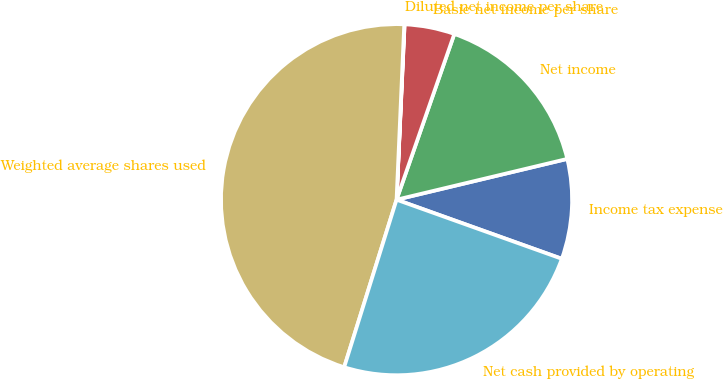<chart> <loc_0><loc_0><loc_500><loc_500><pie_chart><fcel>Income tax expense<fcel>Net income<fcel>Basic net income per share<fcel>Diluted net income per share<fcel>Weighted average shares used<fcel>Net cash provided by operating<nl><fcel>9.2%<fcel>15.93%<fcel>4.61%<fcel>0.03%<fcel>45.88%<fcel>24.36%<nl></chart> 